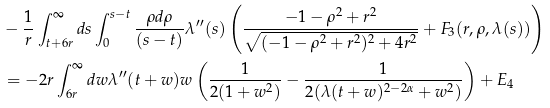<formula> <loc_0><loc_0><loc_500><loc_500>& - \frac { 1 } { r } \int _ { t + 6 r } ^ { \infty } d s \int _ { 0 } ^ { s - t } \frac { \rho d \rho } { ( s - t ) } \lambda ^ { \prime \prime } ( s ) \left ( \frac { - 1 - \rho ^ { 2 } + r ^ { 2 } } { \sqrt { ( - 1 - \rho ^ { 2 } + r ^ { 2 } ) ^ { 2 } + 4 r ^ { 2 } } } + F _ { 3 } ( r , \rho , \lambda ( s ) ) \right ) \\ & = - 2 r \int _ { 6 r } ^ { \infty } d w \lambda ^ { \prime \prime } ( t + w ) w \left ( \frac { 1 } { 2 ( 1 + w ^ { 2 } ) } - \frac { 1 } { 2 ( \lambda ( t + w ) ^ { 2 - 2 \alpha } + w ^ { 2 } ) } \right ) + E _ { 4 }</formula> 